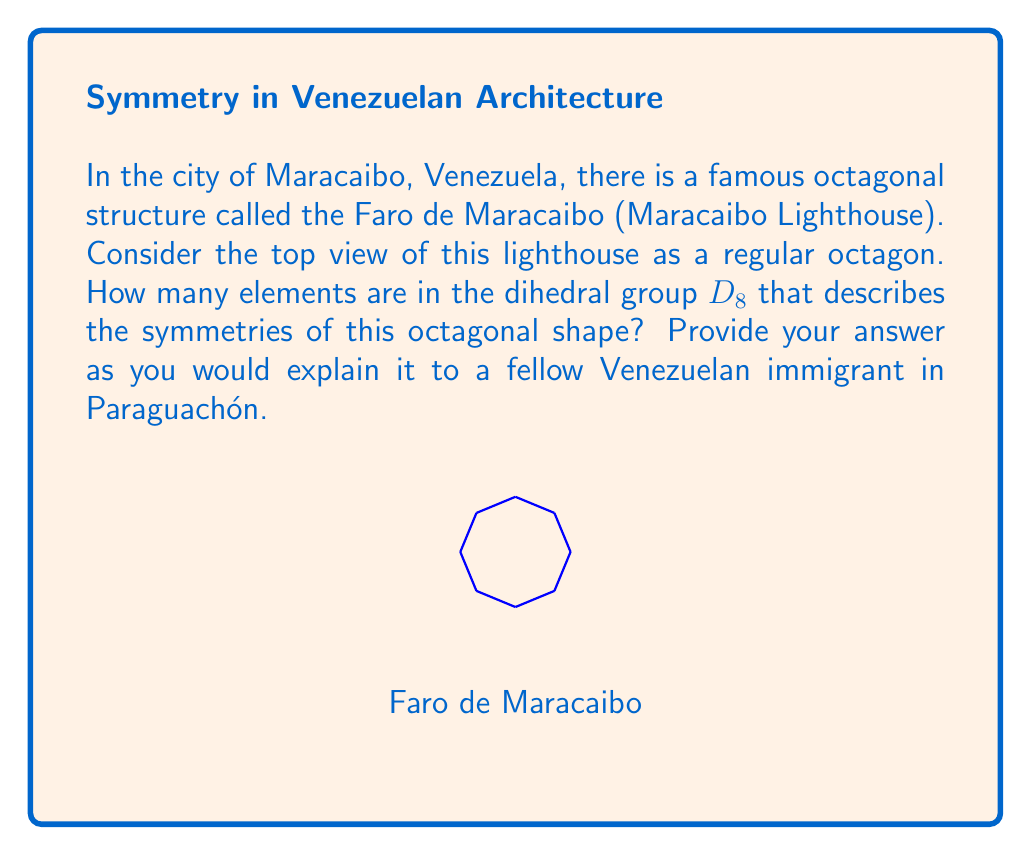Provide a solution to this math problem. To find the number of elements in the dihedral group $D_8$, we need to consider two types of symmetries:

1. Rotational symmetries:
   - The octagon can be rotated by multiples of 45° (360°/8) to coincide with itself.
   - There are 8 rotations: 0°, 45°, 90°, 135°, 180°, 225°, 270°, 315°.

2. Reflection symmetries:
   - The octagon has 8 lines of symmetry: 4 passing through opposite vertices and 4 passing through the midpoints of opposite sides.

The total number of symmetries is the sum of rotations and reflections:

$$ |D_8| = \text{number of rotations} + \text{number of reflections} $$
$$ |D_8| = 8 + 8 = 16 $$

In group theory terms:
- The order of the cyclic subgroup of rotations is 8.
- There are 8 reflection elements.
- The total order of the dihedral group $D_8$ is 16.

This means that there are 16 different ways to move the octagon so that it looks the same as when we started, just like how the Faro de Maracaibo looks the same from different angles.
Answer: 16 elements 